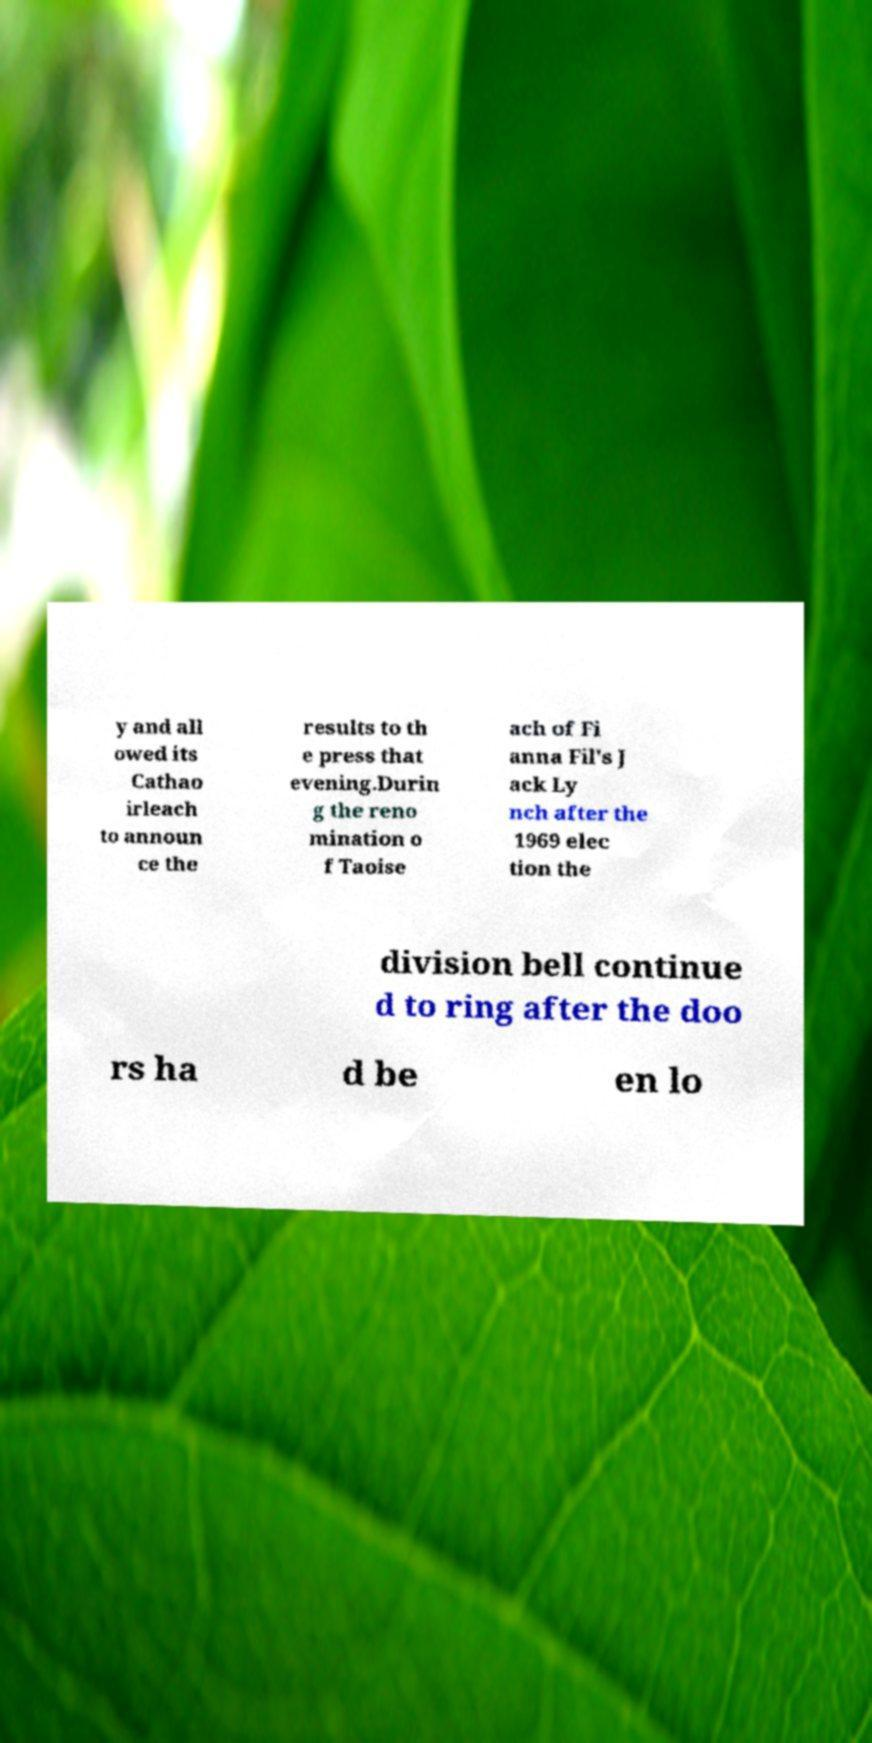Could you extract and type out the text from this image? y and all owed its Cathao irleach to announ ce the results to th e press that evening.Durin g the reno mination o f Taoise ach of Fi anna Fil's J ack Ly nch after the 1969 elec tion the division bell continue d to ring after the doo rs ha d be en lo 